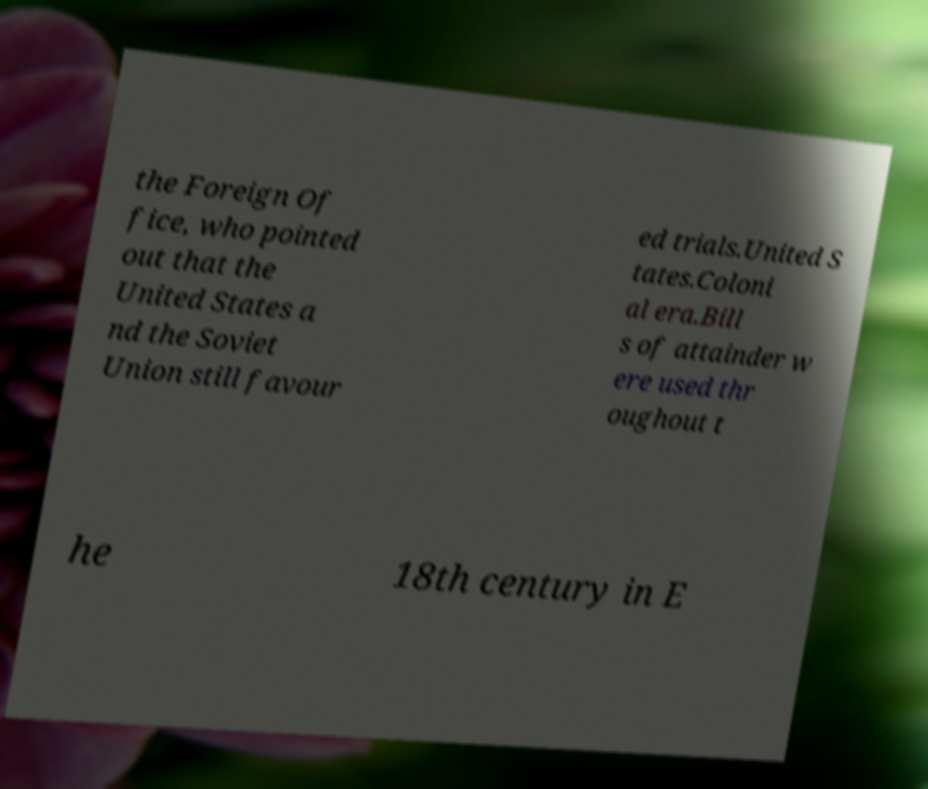For documentation purposes, I need the text within this image transcribed. Could you provide that? the Foreign Of fice, who pointed out that the United States a nd the Soviet Union still favour ed trials.United S tates.Coloni al era.Bill s of attainder w ere used thr oughout t he 18th century in E 